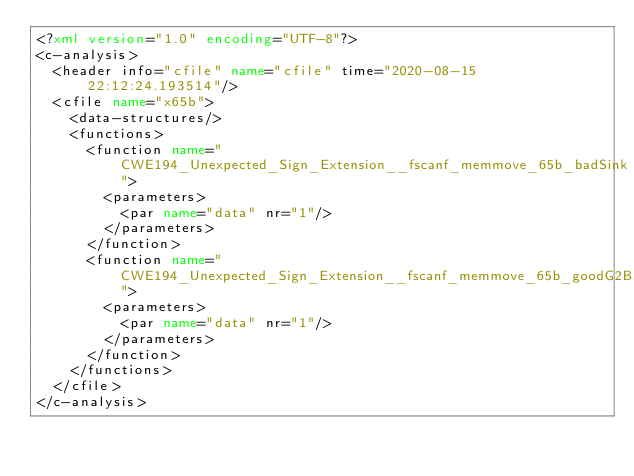Convert code to text. <code><loc_0><loc_0><loc_500><loc_500><_XML_><?xml version="1.0" encoding="UTF-8"?>
<c-analysis>
  <header info="cfile" name="cfile" time="2020-08-15 22:12:24.193514"/>
  <cfile name="x65b">
    <data-structures/>
    <functions>
      <function name="CWE194_Unexpected_Sign_Extension__fscanf_memmove_65b_badSink">
        <parameters>
          <par name="data" nr="1"/>
        </parameters>
      </function>
      <function name="CWE194_Unexpected_Sign_Extension__fscanf_memmove_65b_goodG2BSink">
        <parameters>
          <par name="data" nr="1"/>
        </parameters>
      </function>
    </functions>
  </cfile>
</c-analysis>
</code> 